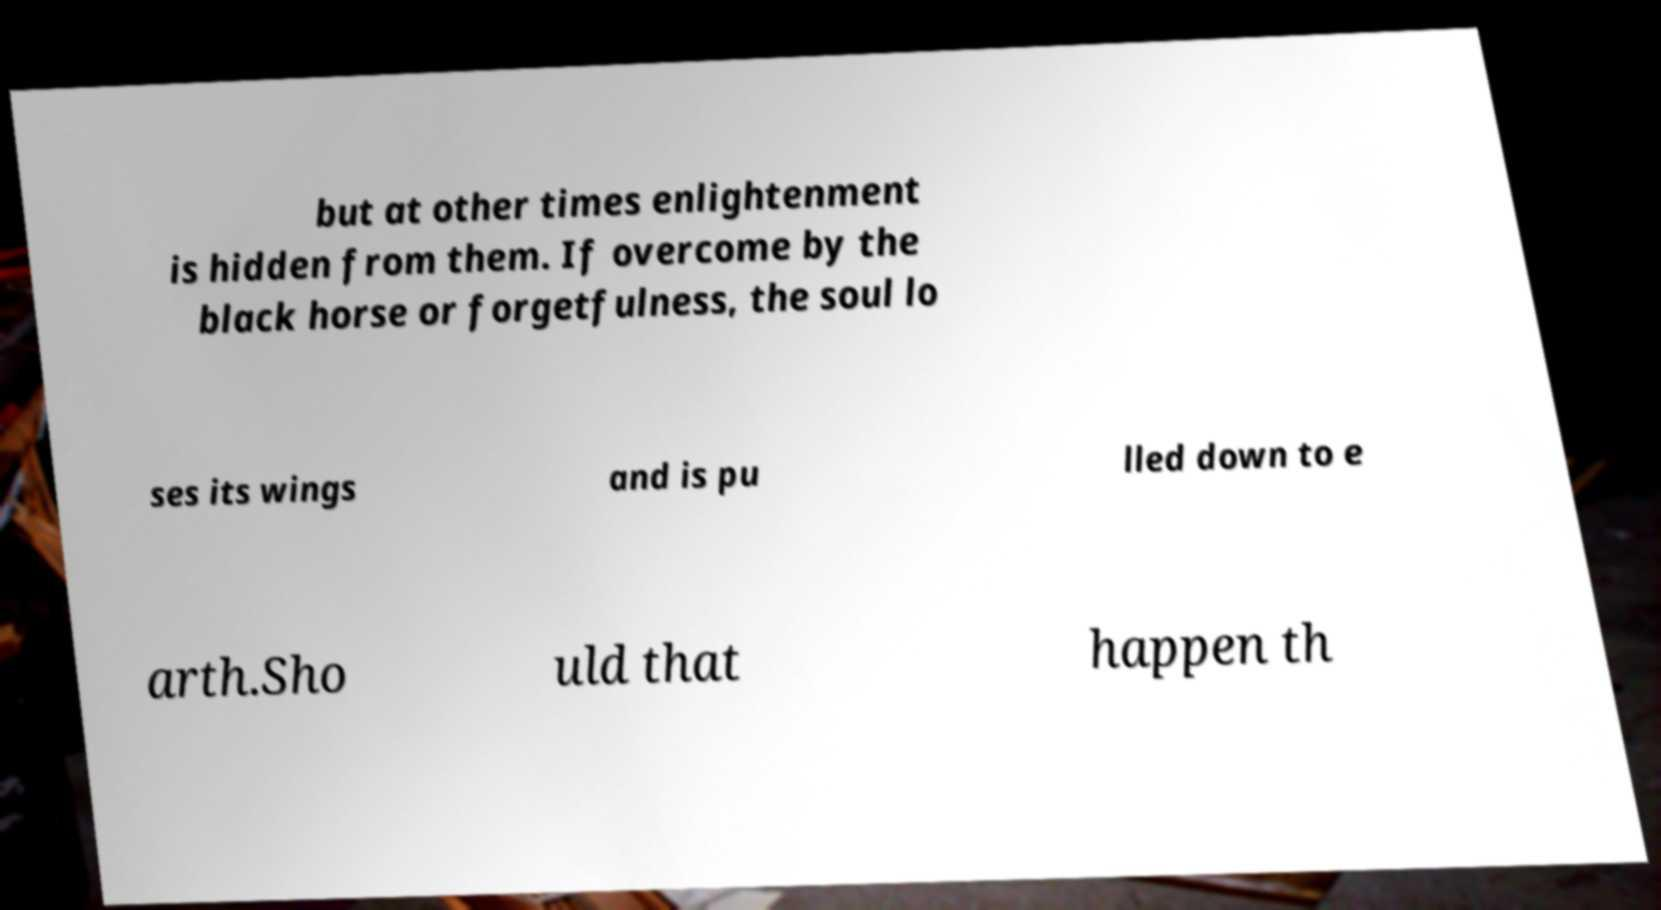Could you assist in decoding the text presented in this image and type it out clearly? but at other times enlightenment is hidden from them. If overcome by the black horse or forgetfulness, the soul lo ses its wings and is pu lled down to e arth.Sho uld that happen th 